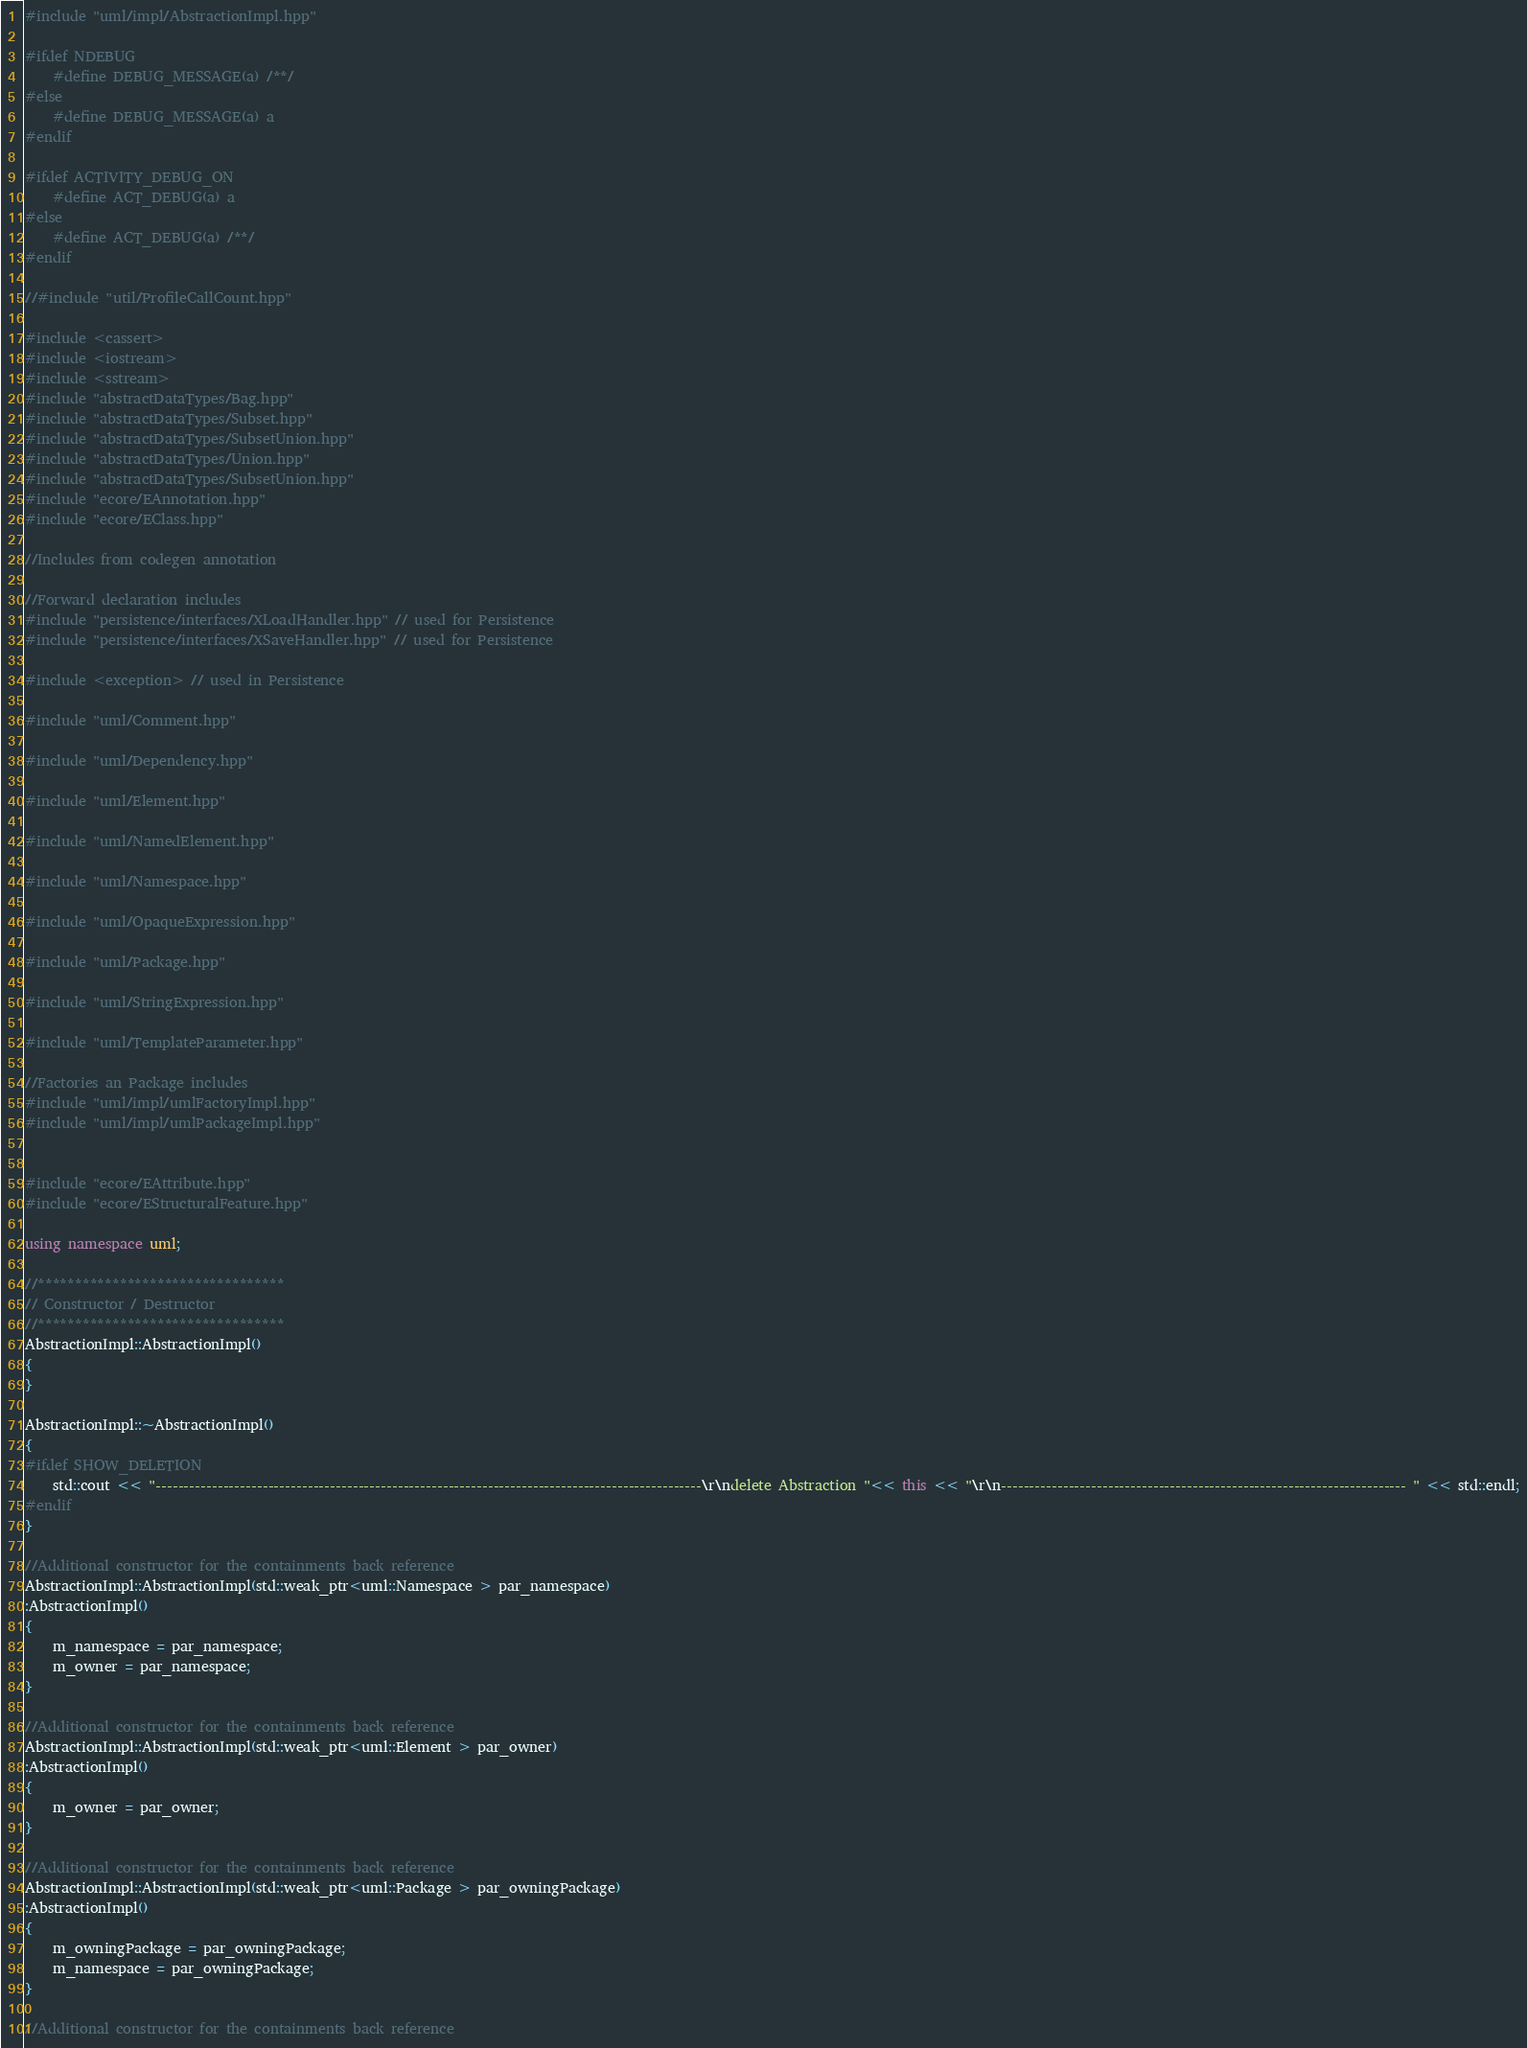Convert code to text. <code><loc_0><loc_0><loc_500><loc_500><_C++_>#include "uml/impl/AbstractionImpl.hpp"

#ifdef NDEBUG
	#define DEBUG_MESSAGE(a) /**/
#else
	#define DEBUG_MESSAGE(a) a
#endif

#ifdef ACTIVITY_DEBUG_ON
    #define ACT_DEBUG(a) a
#else
    #define ACT_DEBUG(a) /**/
#endif

//#include "util/ProfileCallCount.hpp"

#include <cassert>
#include <iostream>
#include <sstream>
#include "abstractDataTypes/Bag.hpp"
#include "abstractDataTypes/Subset.hpp"
#include "abstractDataTypes/SubsetUnion.hpp"
#include "abstractDataTypes/Union.hpp"
#include "abstractDataTypes/SubsetUnion.hpp"
#include "ecore/EAnnotation.hpp"
#include "ecore/EClass.hpp"

//Includes from codegen annotation

//Forward declaration includes
#include "persistence/interfaces/XLoadHandler.hpp" // used for Persistence
#include "persistence/interfaces/XSaveHandler.hpp" // used for Persistence

#include <exception> // used in Persistence

#include "uml/Comment.hpp"

#include "uml/Dependency.hpp"

#include "uml/Element.hpp"

#include "uml/NamedElement.hpp"

#include "uml/Namespace.hpp"

#include "uml/OpaqueExpression.hpp"

#include "uml/Package.hpp"

#include "uml/StringExpression.hpp"

#include "uml/TemplateParameter.hpp"

//Factories an Package includes
#include "uml/impl/umlFactoryImpl.hpp"
#include "uml/impl/umlPackageImpl.hpp"


#include "ecore/EAttribute.hpp"
#include "ecore/EStructuralFeature.hpp"

using namespace uml;

//*********************************
// Constructor / Destructor
//*********************************
AbstractionImpl::AbstractionImpl()
{	
}

AbstractionImpl::~AbstractionImpl()
{
#ifdef SHOW_DELETION
	std::cout << "-------------------------------------------------------------------------------------------------\r\ndelete Abstraction "<< this << "\r\n------------------------------------------------------------------------ " << std::endl;
#endif
}

//Additional constructor for the containments back reference
AbstractionImpl::AbstractionImpl(std::weak_ptr<uml::Namespace > par_namespace)
:AbstractionImpl()
{
	m_namespace = par_namespace;
	m_owner = par_namespace;
}

//Additional constructor for the containments back reference
AbstractionImpl::AbstractionImpl(std::weak_ptr<uml::Element > par_owner)
:AbstractionImpl()
{
	m_owner = par_owner;
}

//Additional constructor for the containments back reference
AbstractionImpl::AbstractionImpl(std::weak_ptr<uml::Package > par_owningPackage)
:AbstractionImpl()
{
	m_owningPackage = par_owningPackage;
	m_namespace = par_owningPackage;
}

//Additional constructor for the containments back reference</code> 